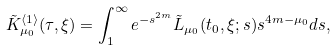Convert formula to latex. <formula><loc_0><loc_0><loc_500><loc_500>\tilde { K } _ { \mu _ { 0 } } ^ { \langle 1 \rangle } ( \tau , \xi ) = \int _ { 1 } ^ { \infty } e ^ { - s ^ { 2 m } } \tilde { L } _ { \mu _ { 0 } } ( t _ { 0 } , \xi ; s ) s ^ { 4 m - \mu _ { 0 } } d s ,</formula> 